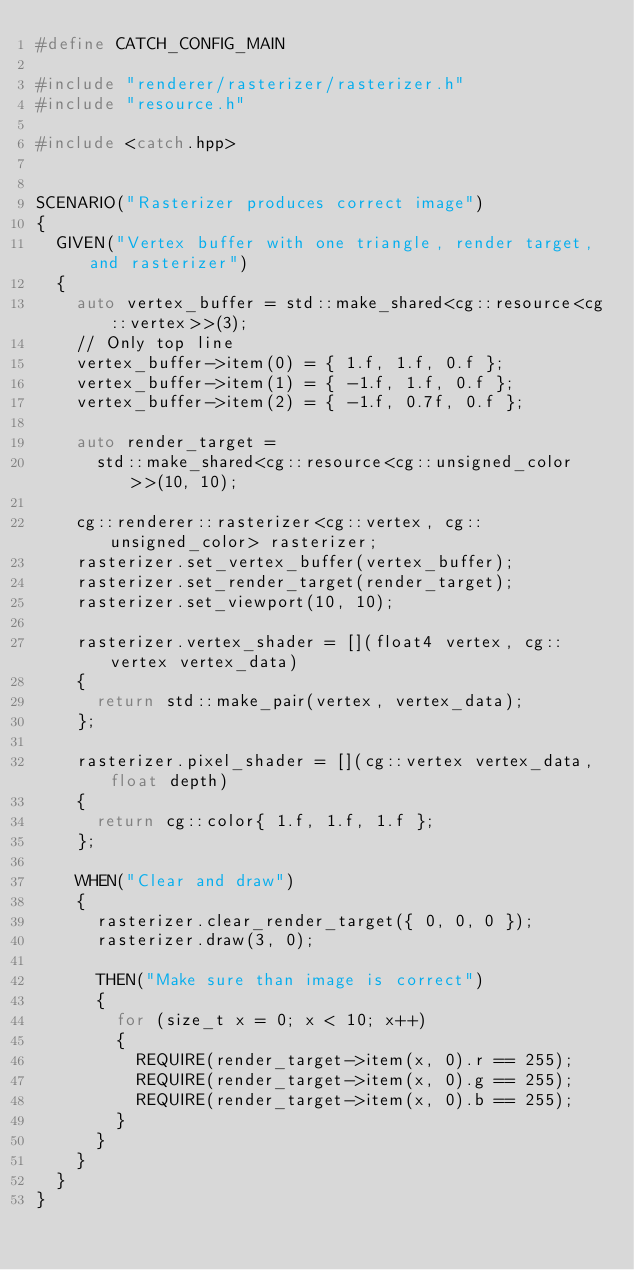<code> <loc_0><loc_0><loc_500><loc_500><_C++_>#define CATCH_CONFIG_MAIN

#include "renderer/rasterizer/rasterizer.h"
#include "resource.h"

#include <catch.hpp>


SCENARIO("Rasterizer produces correct image")
{
  GIVEN("Vertex buffer with one triangle, render target, and rasterizer")
  {
    auto vertex_buffer = std::make_shared<cg::resource<cg::vertex>>(3);
    // Only top line
    vertex_buffer->item(0) = { 1.f, 1.f, 0.f };
    vertex_buffer->item(1) = { -1.f, 1.f, 0.f };
    vertex_buffer->item(2) = { -1.f, 0.7f, 0.f };

    auto render_target =
      std::make_shared<cg::resource<cg::unsigned_color>>(10, 10);

    cg::renderer::rasterizer<cg::vertex, cg::unsigned_color> rasterizer;
    rasterizer.set_vertex_buffer(vertex_buffer);
    rasterizer.set_render_target(render_target);
    rasterizer.set_viewport(10, 10);

    rasterizer.vertex_shader = [](float4 vertex, cg::vertex vertex_data)
    {
      return std::make_pair(vertex, vertex_data);
    };

    rasterizer.pixel_shader = [](cg::vertex vertex_data, float depth)
    {
      return cg::color{ 1.f, 1.f, 1.f };
    };

    WHEN("Clear and draw")
    {
      rasterizer.clear_render_target({ 0, 0, 0 });
      rasterizer.draw(3, 0);

      THEN("Make sure than image is correct")
      {
        for (size_t x = 0; x < 10; x++)
        {
          REQUIRE(render_target->item(x, 0).r == 255);
          REQUIRE(render_target->item(x, 0).g == 255);
          REQUIRE(render_target->item(x, 0).b == 255);
        }
      }
    }
  }
}
</code> 